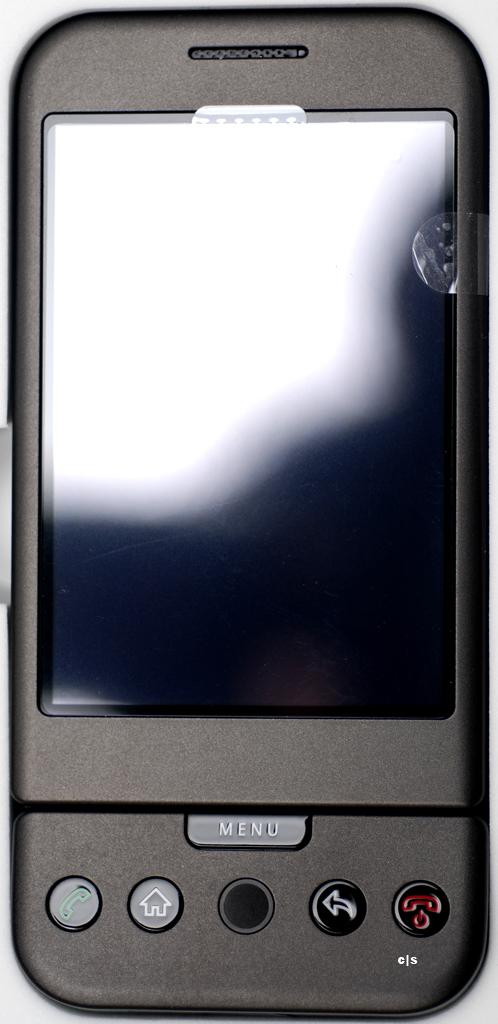What is the the button say in the middle?
Ensure brevity in your answer.  Menu. 